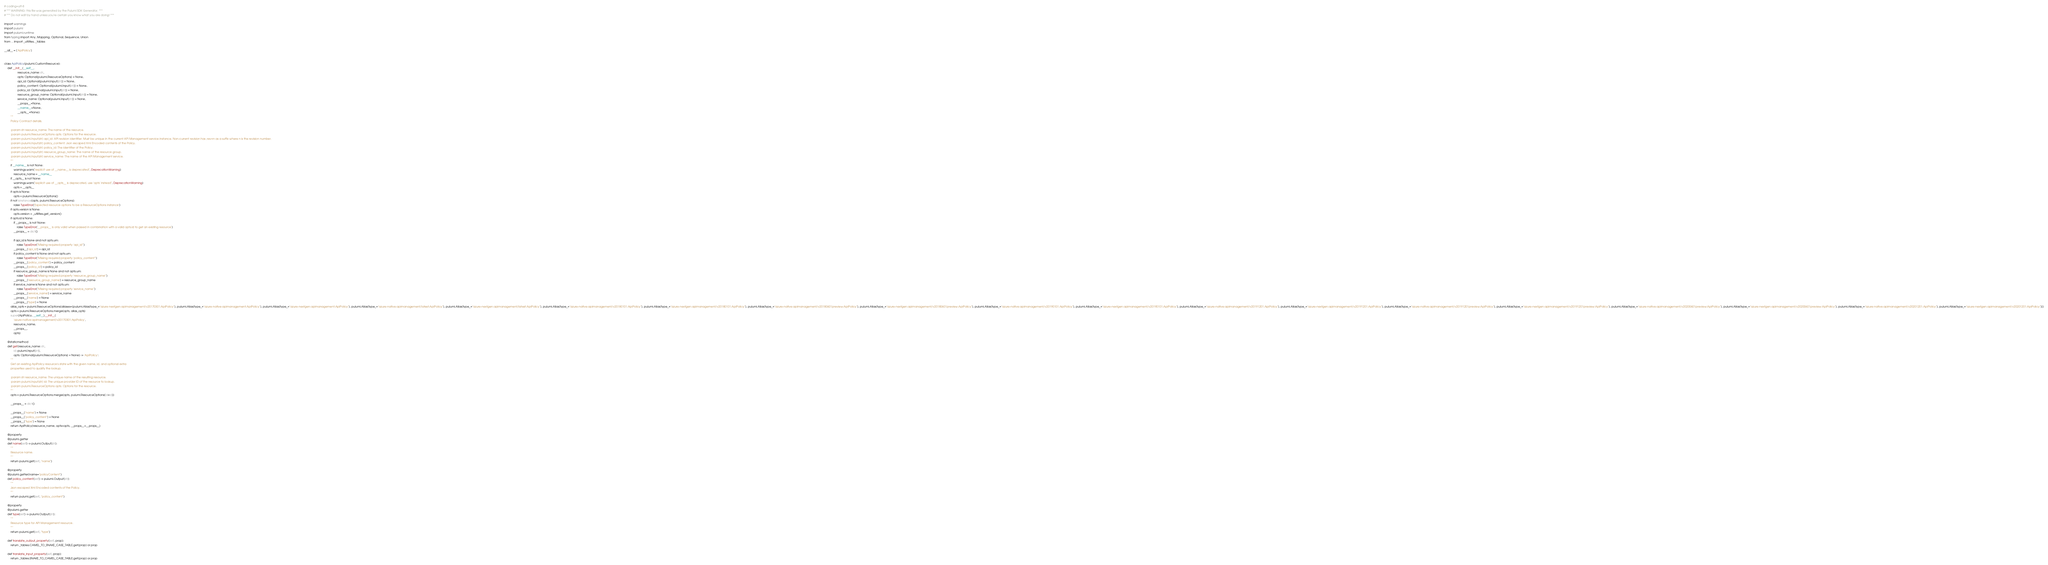<code> <loc_0><loc_0><loc_500><loc_500><_Python_># coding=utf-8
# *** WARNING: this file was generated by the Pulumi SDK Generator. ***
# *** Do not edit by hand unless you're certain you know what you are doing! ***

import warnings
import pulumi
import pulumi.runtime
from typing import Any, Mapping, Optional, Sequence, Union
from ... import _utilities, _tables

__all__ = ['ApiPolicy']


class ApiPolicy(pulumi.CustomResource):
    def __init__(__self__,
                 resource_name: str,
                 opts: Optional[pulumi.ResourceOptions] = None,
                 api_id: Optional[pulumi.Input[str]] = None,
                 policy_content: Optional[pulumi.Input[str]] = None,
                 policy_id: Optional[pulumi.Input[str]] = None,
                 resource_group_name: Optional[pulumi.Input[str]] = None,
                 service_name: Optional[pulumi.Input[str]] = None,
                 __props__=None,
                 __name__=None,
                 __opts__=None):
        """
        Policy Contract details.

        :param str resource_name: The name of the resource.
        :param pulumi.ResourceOptions opts: Options for the resource.
        :param pulumi.Input[str] api_id: API revision identifier. Must be unique in the current API Management service instance. Non-current revision has ;rev=n as a suffix where n is the revision number.
        :param pulumi.Input[str] policy_content: Json escaped Xml Encoded contents of the Policy.
        :param pulumi.Input[str] policy_id: The identifier of the Policy.
        :param pulumi.Input[str] resource_group_name: The name of the resource group.
        :param pulumi.Input[str] service_name: The name of the API Management service.
        """
        if __name__ is not None:
            warnings.warn("explicit use of __name__ is deprecated", DeprecationWarning)
            resource_name = __name__
        if __opts__ is not None:
            warnings.warn("explicit use of __opts__ is deprecated, use 'opts' instead", DeprecationWarning)
            opts = __opts__
        if opts is None:
            opts = pulumi.ResourceOptions()
        if not isinstance(opts, pulumi.ResourceOptions):
            raise TypeError('Expected resource options to be a ResourceOptions instance')
        if opts.version is None:
            opts.version = _utilities.get_version()
        if opts.id is None:
            if __props__ is not None:
                raise TypeError('__props__ is only valid when passed in combination with a valid opts.id to get an existing resource')
            __props__ = dict()

            if api_id is None and not opts.urn:
                raise TypeError("Missing required property 'api_id'")
            __props__['api_id'] = api_id
            if policy_content is None and not opts.urn:
                raise TypeError("Missing required property 'policy_content'")
            __props__['policy_content'] = policy_content
            __props__['policy_id'] = policy_id
            if resource_group_name is None and not opts.urn:
                raise TypeError("Missing required property 'resource_group_name'")
            __props__['resource_group_name'] = resource_group_name
            if service_name is None and not opts.urn:
                raise TypeError("Missing required property 'service_name'")
            __props__['service_name'] = service_name
            __props__['name'] = None
            __props__['type'] = None
        alias_opts = pulumi.ResourceOptions(aliases=[pulumi.Alias(type_="azure-nextgen:apimanagement/v20170301:ApiPolicy"), pulumi.Alias(type_="azure-native:apimanagement:ApiPolicy"), pulumi.Alias(type_="azure-nextgen:apimanagement:ApiPolicy"), pulumi.Alias(type_="azure-native:apimanagement/latest:ApiPolicy"), pulumi.Alias(type_="azure-nextgen:apimanagement/latest:ApiPolicy"), pulumi.Alias(type_="azure-native:apimanagement/v20180101:ApiPolicy"), pulumi.Alias(type_="azure-nextgen:apimanagement/v20180101:ApiPolicy"), pulumi.Alias(type_="azure-native:apimanagement/v20180601preview:ApiPolicy"), pulumi.Alias(type_="azure-nextgen:apimanagement/v20180601preview:ApiPolicy"), pulumi.Alias(type_="azure-native:apimanagement/v20190101:ApiPolicy"), pulumi.Alias(type_="azure-nextgen:apimanagement/v20190101:ApiPolicy"), pulumi.Alias(type_="azure-native:apimanagement/v20191201:ApiPolicy"), pulumi.Alias(type_="azure-nextgen:apimanagement/v20191201:ApiPolicy"), pulumi.Alias(type_="azure-native:apimanagement/v20191201preview:ApiPolicy"), pulumi.Alias(type_="azure-nextgen:apimanagement/v20191201preview:ApiPolicy"), pulumi.Alias(type_="azure-native:apimanagement/v20200601preview:ApiPolicy"), pulumi.Alias(type_="azure-nextgen:apimanagement/v20200601preview:ApiPolicy"), pulumi.Alias(type_="azure-native:apimanagement/v20201201:ApiPolicy"), pulumi.Alias(type_="azure-nextgen:apimanagement/v20201201:ApiPolicy")])
        opts = pulumi.ResourceOptions.merge(opts, alias_opts)
        super(ApiPolicy, __self__).__init__(
            'azure-native:apimanagement/v20170301:ApiPolicy',
            resource_name,
            __props__,
            opts)

    @staticmethod
    def get(resource_name: str,
            id: pulumi.Input[str],
            opts: Optional[pulumi.ResourceOptions] = None) -> 'ApiPolicy':
        """
        Get an existing ApiPolicy resource's state with the given name, id, and optional extra
        properties used to qualify the lookup.

        :param str resource_name: The unique name of the resulting resource.
        :param pulumi.Input[str] id: The unique provider ID of the resource to lookup.
        :param pulumi.ResourceOptions opts: Options for the resource.
        """
        opts = pulumi.ResourceOptions.merge(opts, pulumi.ResourceOptions(id=id))

        __props__ = dict()

        __props__["name"] = None
        __props__["policy_content"] = None
        __props__["type"] = None
        return ApiPolicy(resource_name, opts=opts, __props__=__props__)

    @property
    @pulumi.getter
    def name(self) -> pulumi.Output[str]:
        """
        Resource name.
        """
        return pulumi.get(self, "name")

    @property
    @pulumi.getter(name="policyContent")
    def policy_content(self) -> pulumi.Output[str]:
        """
        Json escaped Xml Encoded contents of the Policy.
        """
        return pulumi.get(self, "policy_content")

    @property
    @pulumi.getter
    def type(self) -> pulumi.Output[str]:
        """
        Resource type for API Management resource.
        """
        return pulumi.get(self, "type")

    def translate_output_property(self, prop):
        return _tables.CAMEL_TO_SNAKE_CASE_TABLE.get(prop) or prop

    def translate_input_property(self, prop):
        return _tables.SNAKE_TO_CAMEL_CASE_TABLE.get(prop) or prop

</code> 